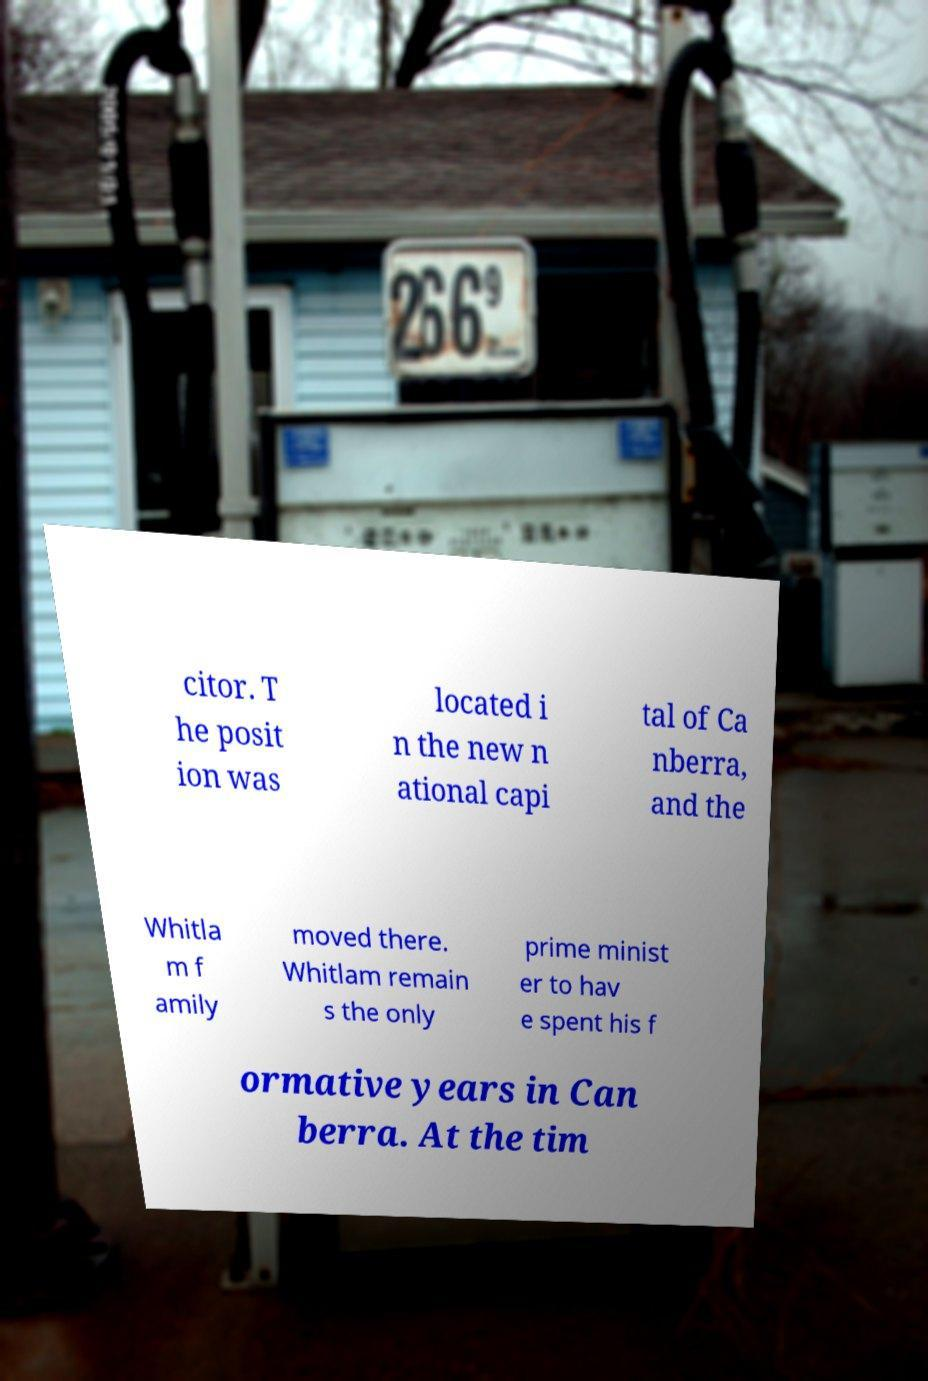There's text embedded in this image that I need extracted. Can you transcribe it verbatim? citor. T he posit ion was located i n the new n ational capi tal of Ca nberra, and the Whitla m f amily moved there. Whitlam remain s the only prime minist er to hav e spent his f ormative years in Can berra. At the tim 